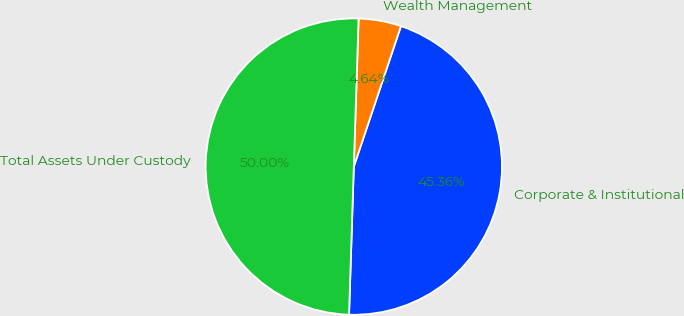Convert chart to OTSL. <chart><loc_0><loc_0><loc_500><loc_500><pie_chart><fcel>Corporate & Institutional<fcel>Wealth Management<fcel>Total Assets Under Custody<nl><fcel>45.36%<fcel>4.64%<fcel>50.0%<nl></chart> 